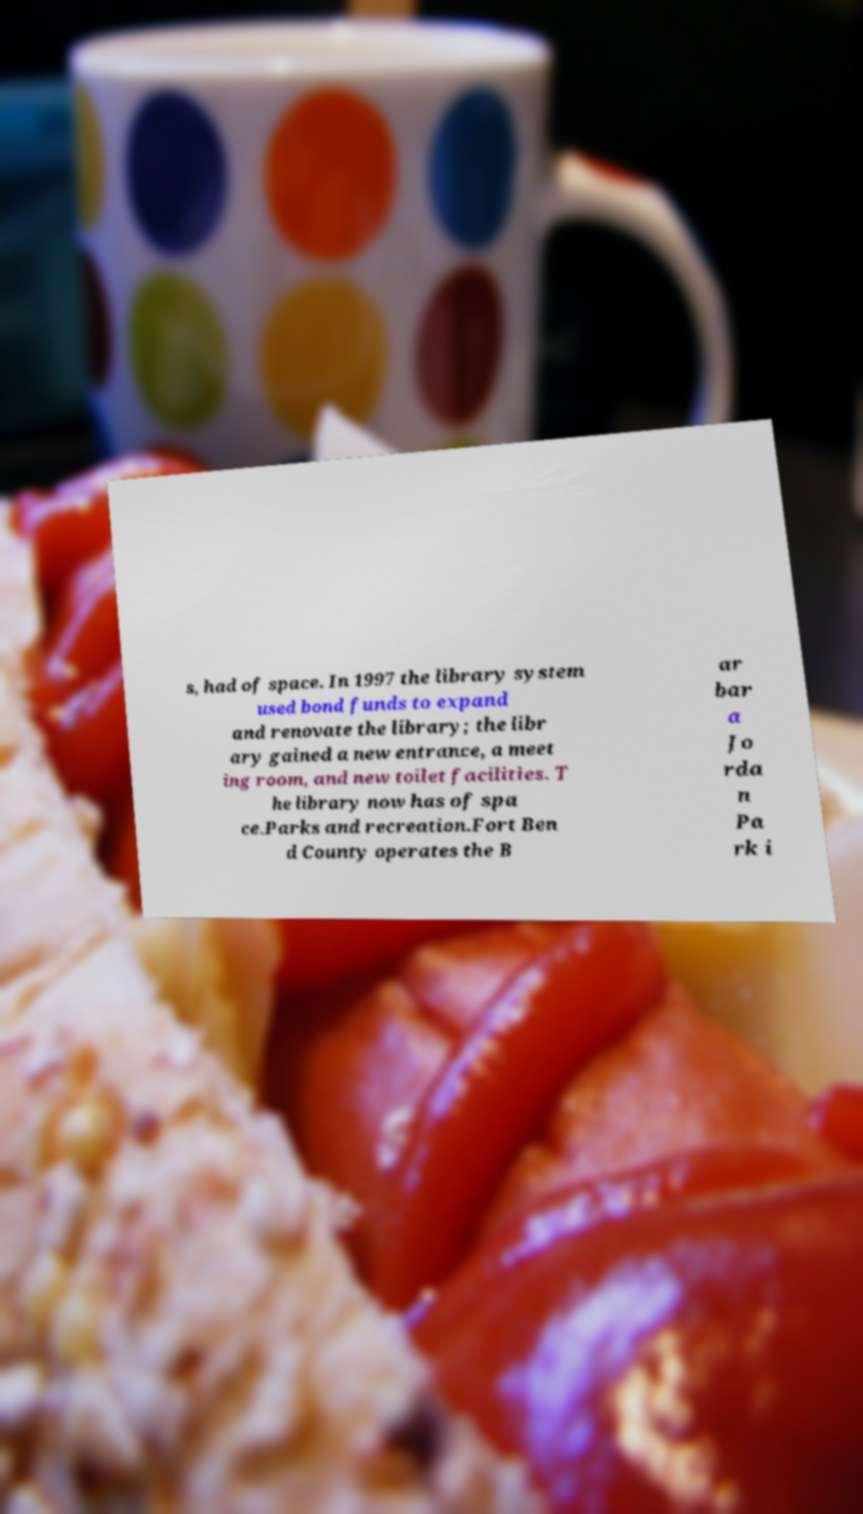Could you assist in decoding the text presented in this image and type it out clearly? s, had of space. In 1997 the library system used bond funds to expand and renovate the library; the libr ary gained a new entrance, a meet ing room, and new toilet facilities. T he library now has of spa ce.Parks and recreation.Fort Ben d County operates the B ar bar a Jo rda n Pa rk i 